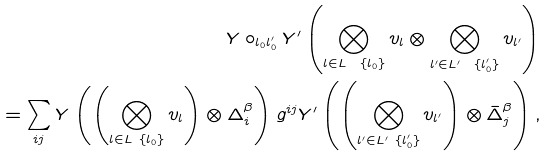Convert formula to latex. <formula><loc_0><loc_0><loc_500><loc_500>Y \circ _ { l _ { 0 } l _ { 0 } ^ { \prime } } Y ^ { \prime } \left ( \bigotimes _ { l \in L \ \{ l _ { 0 } \} } v _ { l } \otimes \bigotimes _ { l ^ { \prime } \in L ^ { \prime } \ \{ l _ { 0 } ^ { \prime } \} } v _ { l ^ { \prime } } \right ) \\ = \sum _ { i j } Y \left ( \left ( \bigotimes _ { l \in L \ \{ l _ { 0 } \} } v _ { l } \right ) \otimes \Delta ^ { \beta } _ { i } \right ) g ^ { i j } Y ^ { \prime } \left ( \left ( \bigotimes _ { l ^ { \prime } \in L ^ { \prime } \ \{ l _ { 0 } ^ { \prime } \} } v _ { l ^ { \prime } } \right ) \otimes \bar { \Delta } ^ { \beta } _ { j } \right ) ,</formula> 